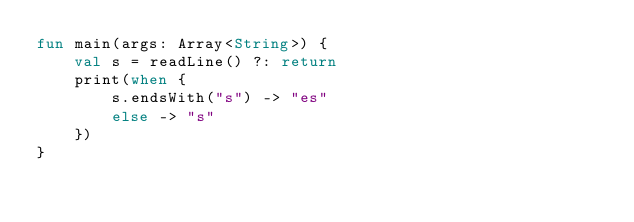Convert code to text. <code><loc_0><loc_0><loc_500><loc_500><_Kotlin_>fun main(args: Array<String>) {
    val s = readLine() ?: return
    print(when {
        s.endsWith("s") -> "es"
        else -> "s"
    })
}</code> 